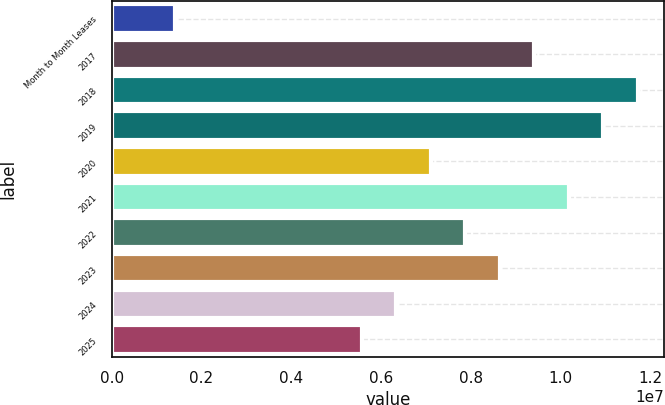Convert chart to OTSL. <chart><loc_0><loc_0><loc_500><loc_500><bar_chart><fcel>Month to Month Leases<fcel>2017<fcel>2018<fcel>2019<fcel>2020<fcel>2021<fcel>2022<fcel>2023<fcel>2024<fcel>2025<nl><fcel>1.40116e+06<fcel>9.41592e+06<fcel>1.17236e+07<fcel>1.09544e+07<fcel>7.10819e+06<fcel>1.01852e+07<fcel>7.87743e+06<fcel>8.64667e+06<fcel>6.33895e+06<fcel>5.56971e+06<nl></chart> 